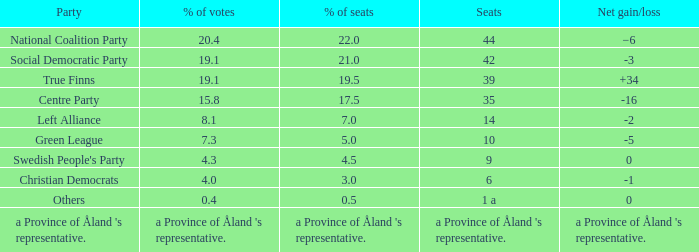Regarding the seats that casted 8.1% of the vote how many seats were held? 14.0. 